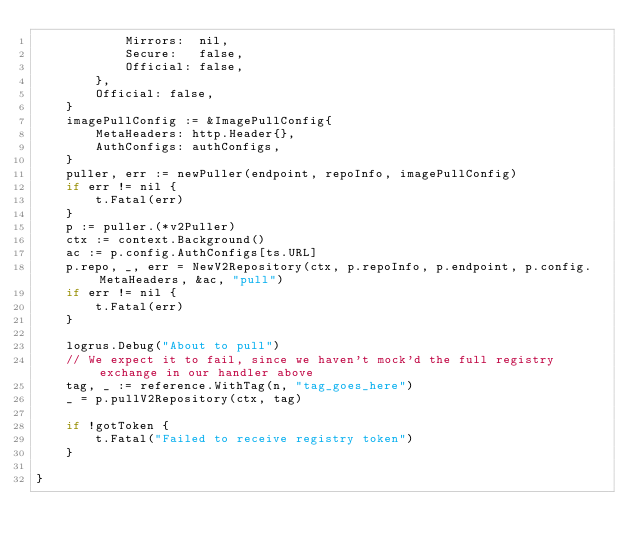Convert code to text. <code><loc_0><loc_0><loc_500><loc_500><_Go_>			Mirrors:  nil,
			Secure:   false,
			Official: false,
		},
		Official: false,
	}
	imagePullConfig := &ImagePullConfig{
		MetaHeaders: http.Header{},
		AuthConfigs: authConfigs,
	}
	puller, err := newPuller(endpoint, repoInfo, imagePullConfig)
	if err != nil {
		t.Fatal(err)
	}
	p := puller.(*v2Puller)
	ctx := context.Background()
	ac := p.config.AuthConfigs[ts.URL]
	p.repo, _, err = NewV2Repository(ctx, p.repoInfo, p.endpoint, p.config.MetaHeaders, &ac, "pull")
	if err != nil {
		t.Fatal(err)
	}

	logrus.Debug("About to pull")
	// We expect it to fail, since we haven't mock'd the full registry exchange in our handler above
	tag, _ := reference.WithTag(n, "tag_goes_here")
	_ = p.pullV2Repository(ctx, tag)

	if !gotToken {
		t.Fatal("Failed to receive registry token")
	}

}
</code> 